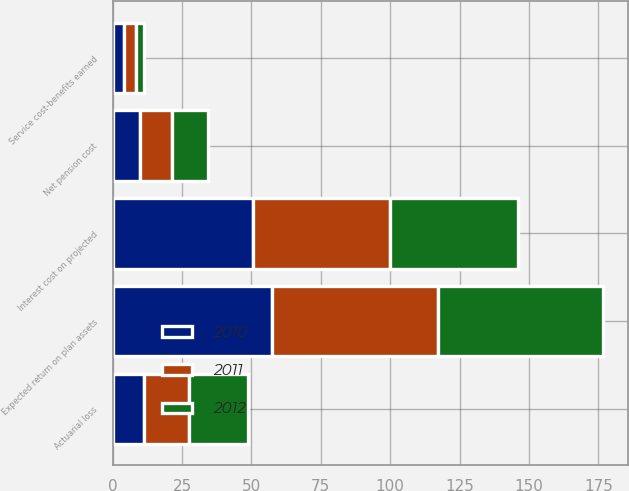Convert chart to OTSL. <chart><loc_0><loc_0><loc_500><loc_500><stacked_bar_chart><ecel><fcel>Service cost-benefits earned<fcel>Interest cost on projected<fcel>Expected return on plan assets<fcel>Actuarial loss<fcel>Net pension cost<nl><fcel>2012<fcel>3<fcel>45.9<fcel>59.7<fcel>21.5<fcel>13.1<nl><fcel>2011<fcel>4.3<fcel>49.4<fcel>59.6<fcel>16.1<fcel>11.7<nl><fcel>2010<fcel>4<fcel>50.6<fcel>57.5<fcel>11.3<fcel>9.7<nl></chart> 